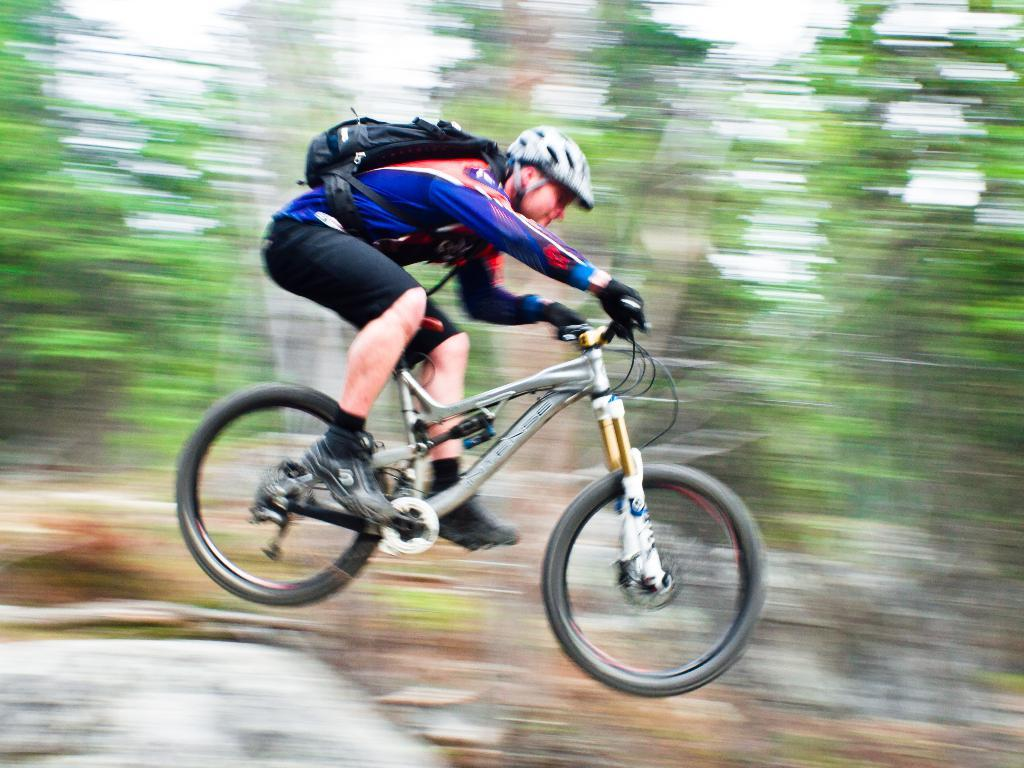Who is present in the image? There is a man in the image. What is the man doing in the image? The man is sitting on a bicycle and jumping while on the bicycle. What can be seen in the background of the image? There are trees and the sky visible in the background of the image. What type of owl can be seen in the image? There is no owl present in the image. What does the government have to do with the man jumping on the bicycle in the image? The government is not mentioned or depicted in the image, so it has no direct connection to the man jumping on the bicycle. 